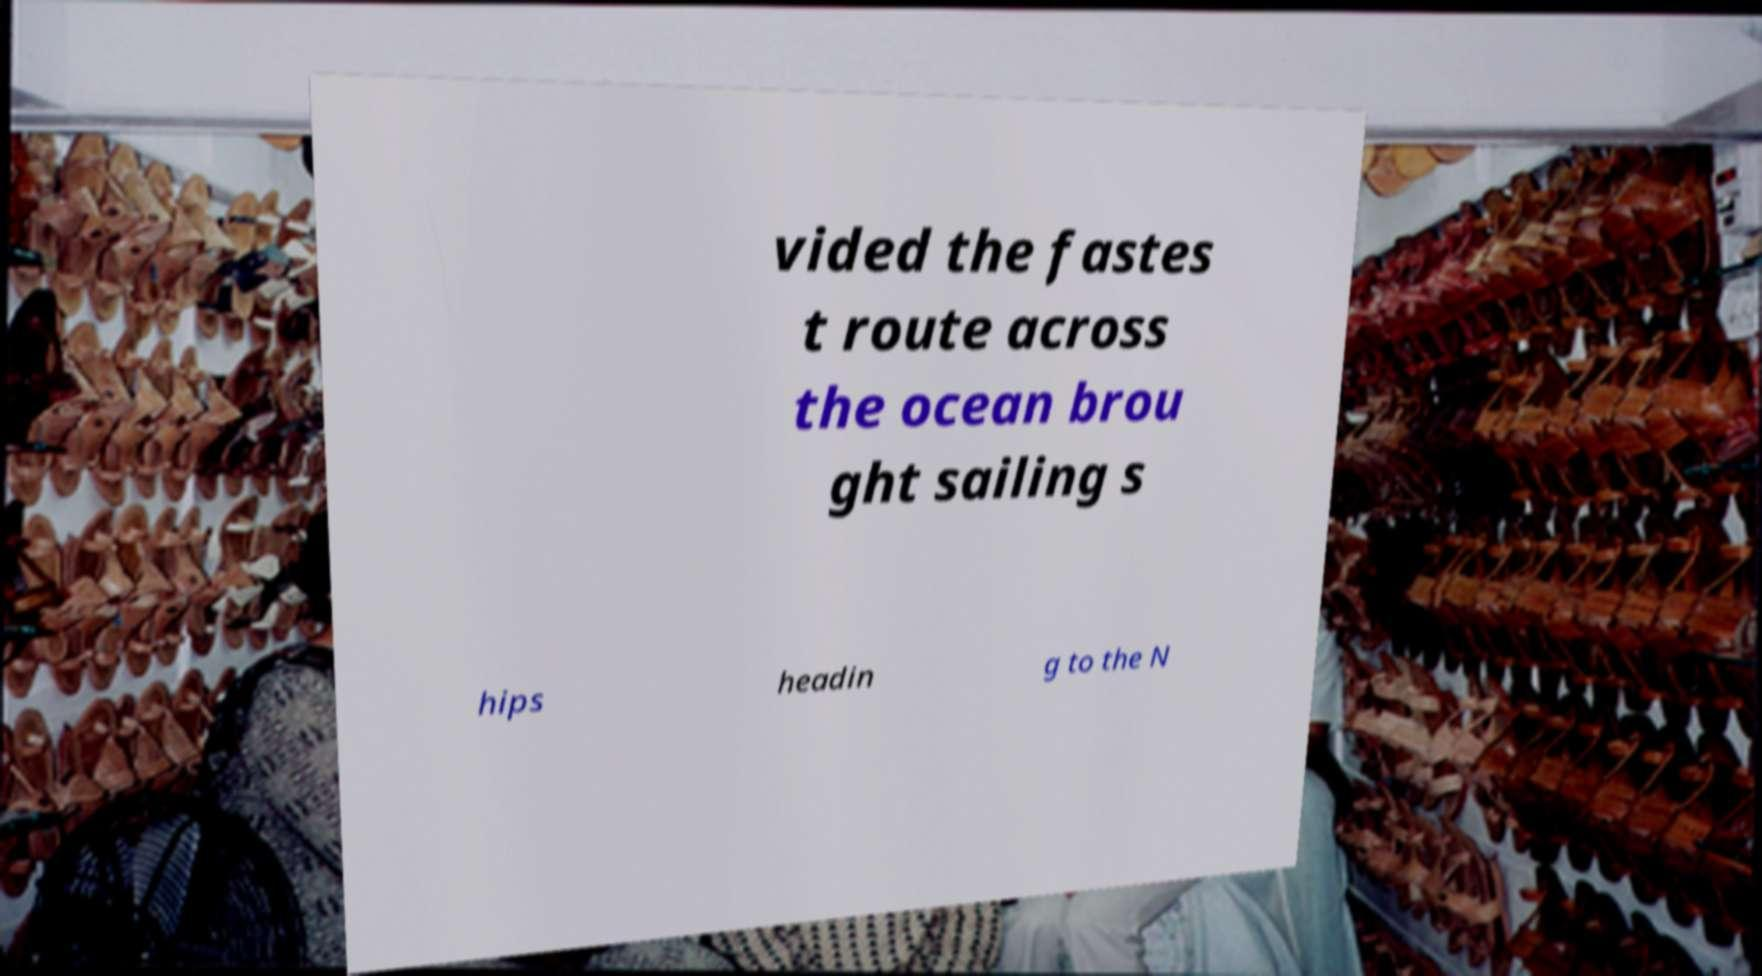Please read and relay the text visible in this image. What does it say? vided the fastes t route across the ocean brou ght sailing s hips headin g to the N 